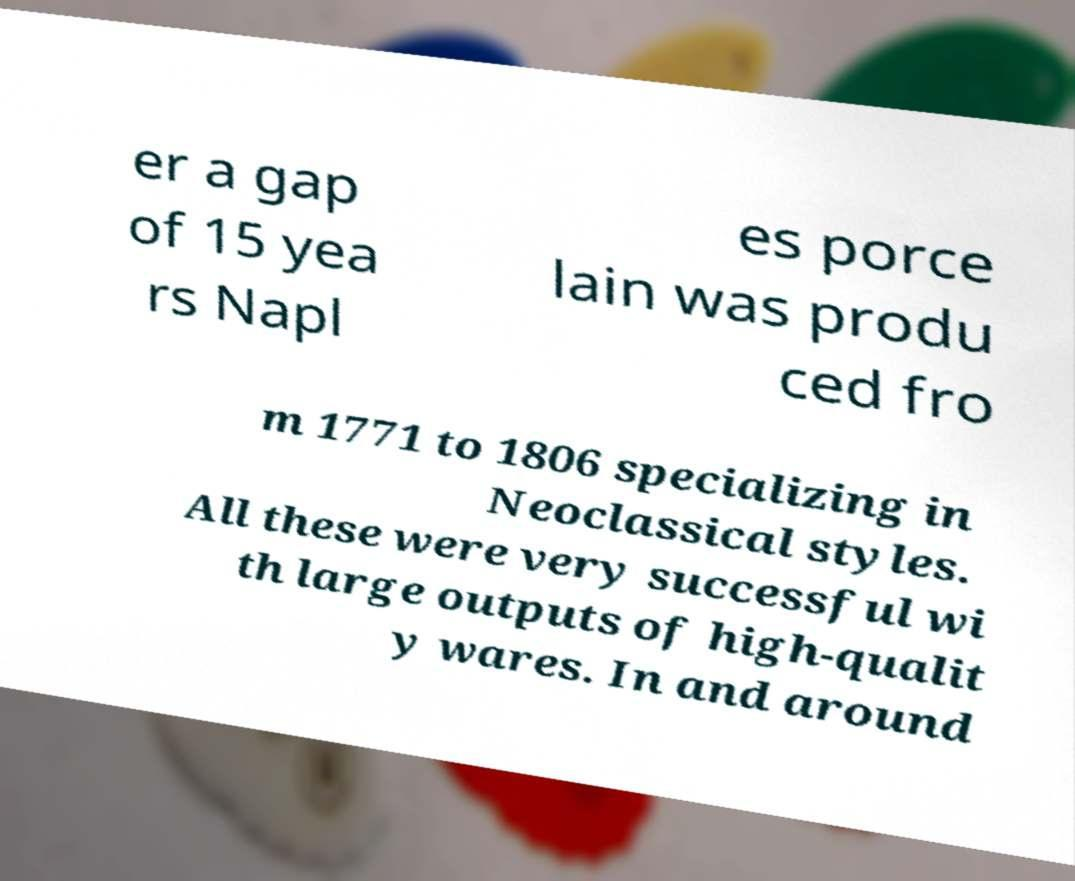Could you assist in decoding the text presented in this image and type it out clearly? er a gap of 15 yea rs Napl es porce lain was produ ced fro m 1771 to 1806 specializing in Neoclassical styles. All these were very successful wi th large outputs of high-qualit y wares. In and around 